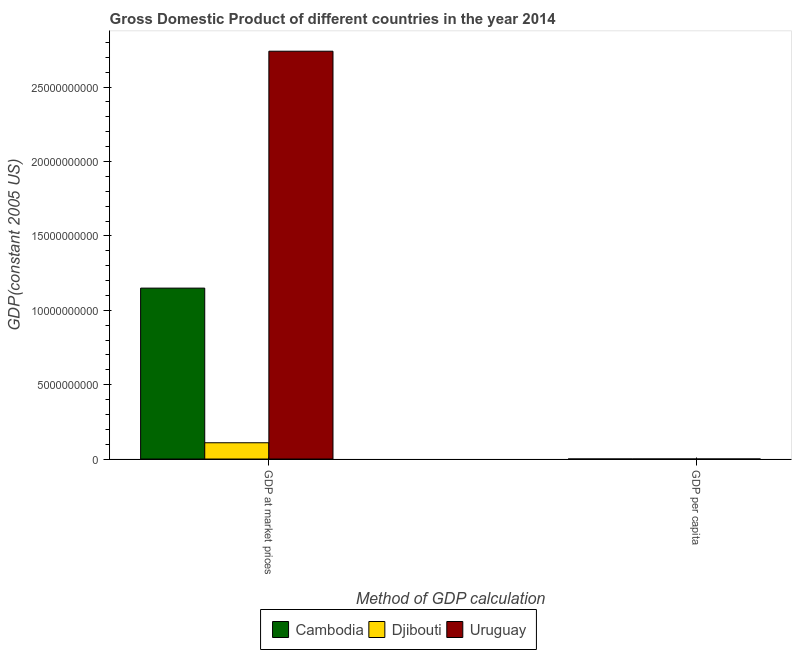How many groups of bars are there?
Provide a short and direct response. 2. Are the number of bars on each tick of the X-axis equal?
Your answer should be very brief. Yes. What is the label of the 2nd group of bars from the left?
Keep it short and to the point. GDP per capita. What is the gdp at market prices in Djibouti?
Your response must be concise. 1.09e+09. Across all countries, what is the maximum gdp per capita?
Provide a short and direct response. 8016.68. Across all countries, what is the minimum gdp at market prices?
Make the answer very short. 1.09e+09. In which country was the gdp at market prices maximum?
Offer a terse response. Uruguay. In which country was the gdp per capita minimum?
Provide a succinct answer. Cambodia. What is the total gdp per capita in the graph?
Give a very brief answer. 1.00e+04. What is the difference between the gdp at market prices in Cambodia and that in Uruguay?
Your answer should be very brief. -1.59e+1. What is the difference between the gdp at market prices in Djibouti and the gdp per capita in Uruguay?
Make the answer very short. 1.09e+09. What is the average gdp per capita per country?
Ensure brevity in your answer.  3338.35. What is the difference between the gdp per capita and gdp at market prices in Uruguay?
Offer a terse response. -2.74e+1. In how many countries, is the gdp at market prices greater than 12000000000 US$?
Offer a very short reply. 1. What is the ratio of the gdp at market prices in Djibouti to that in Uruguay?
Your answer should be very brief. 0.04. Is the gdp per capita in Cambodia less than that in Djibouti?
Give a very brief answer. Yes. What does the 3rd bar from the left in GDP at market prices represents?
Your answer should be very brief. Uruguay. What does the 2nd bar from the right in GDP per capita represents?
Offer a terse response. Djibouti. How many bars are there?
Give a very brief answer. 6. Does the graph contain grids?
Your response must be concise. No. How many legend labels are there?
Offer a very short reply. 3. What is the title of the graph?
Provide a short and direct response. Gross Domestic Product of different countries in the year 2014. What is the label or title of the X-axis?
Your answer should be very brief. Method of GDP calculation. What is the label or title of the Y-axis?
Provide a succinct answer. GDP(constant 2005 US). What is the GDP(constant 2005 US) of Cambodia in GDP at market prices?
Your response must be concise. 1.15e+1. What is the GDP(constant 2005 US) of Djibouti in GDP at market prices?
Give a very brief answer. 1.09e+09. What is the GDP(constant 2005 US) of Uruguay in GDP at market prices?
Your answer should be compact. 2.74e+1. What is the GDP(constant 2005 US) of Cambodia in GDP per capita?
Provide a succinct answer. 749.55. What is the GDP(constant 2005 US) in Djibouti in GDP per capita?
Offer a very short reply. 1248.83. What is the GDP(constant 2005 US) in Uruguay in GDP per capita?
Make the answer very short. 8016.68. Across all Method of GDP calculation, what is the maximum GDP(constant 2005 US) in Cambodia?
Your answer should be very brief. 1.15e+1. Across all Method of GDP calculation, what is the maximum GDP(constant 2005 US) in Djibouti?
Give a very brief answer. 1.09e+09. Across all Method of GDP calculation, what is the maximum GDP(constant 2005 US) in Uruguay?
Provide a succinct answer. 2.74e+1. Across all Method of GDP calculation, what is the minimum GDP(constant 2005 US) of Cambodia?
Your response must be concise. 749.55. Across all Method of GDP calculation, what is the minimum GDP(constant 2005 US) of Djibouti?
Your answer should be very brief. 1248.83. Across all Method of GDP calculation, what is the minimum GDP(constant 2005 US) of Uruguay?
Offer a terse response. 8016.68. What is the total GDP(constant 2005 US) of Cambodia in the graph?
Make the answer very short. 1.15e+1. What is the total GDP(constant 2005 US) in Djibouti in the graph?
Ensure brevity in your answer.  1.09e+09. What is the total GDP(constant 2005 US) of Uruguay in the graph?
Your answer should be compact. 2.74e+1. What is the difference between the GDP(constant 2005 US) of Cambodia in GDP at market prices and that in GDP per capita?
Ensure brevity in your answer.  1.15e+1. What is the difference between the GDP(constant 2005 US) of Djibouti in GDP at market prices and that in GDP per capita?
Offer a terse response. 1.09e+09. What is the difference between the GDP(constant 2005 US) in Uruguay in GDP at market prices and that in GDP per capita?
Your answer should be very brief. 2.74e+1. What is the difference between the GDP(constant 2005 US) of Cambodia in GDP at market prices and the GDP(constant 2005 US) of Djibouti in GDP per capita?
Give a very brief answer. 1.15e+1. What is the difference between the GDP(constant 2005 US) in Cambodia in GDP at market prices and the GDP(constant 2005 US) in Uruguay in GDP per capita?
Provide a succinct answer. 1.15e+1. What is the difference between the GDP(constant 2005 US) in Djibouti in GDP at market prices and the GDP(constant 2005 US) in Uruguay in GDP per capita?
Provide a succinct answer. 1.09e+09. What is the average GDP(constant 2005 US) in Cambodia per Method of GDP calculation?
Provide a succinct answer. 5.74e+09. What is the average GDP(constant 2005 US) of Djibouti per Method of GDP calculation?
Your answer should be very brief. 5.47e+08. What is the average GDP(constant 2005 US) in Uruguay per Method of GDP calculation?
Your answer should be compact. 1.37e+1. What is the difference between the GDP(constant 2005 US) in Cambodia and GDP(constant 2005 US) in Djibouti in GDP at market prices?
Your response must be concise. 1.04e+1. What is the difference between the GDP(constant 2005 US) of Cambodia and GDP(constant 2005 US) of Uruguay in GDP at market prices?
Your response must be concise. -1.59e+1. What is the difference between the GDP(constant 2005 US) in Djibouti and GDP(constant 2005 US) in Uruguay in GDP at market prices?
Provide a succinct answer. -2.63e+1. What is the difference between the GDP(constant 2005 US) of Cambodia and GDP(constant 2005 US) of Djibouti in GDP per capita?
Give a very brief answer. -499.28. What is the difference between the GDP(constant 2005 US) in Cambodia and GDP(constant 2005 US) in Uruguay in GDP per capita?
Give a very brief answer. -7267.13. What is the difference between the GDP(constant 2005 US) of Djibouti and GDP(constant 2005 US) of Uruguay in GDP per capita?
Your answer should be very brief. -6767.85. What is the ratio of the GDP(constant 2005 US) in Cambodia in GDP at market prices to that in GDP per capita?
Ensure brevity in your answer.  1.53e+07. What is the ratio of the GDP(constant 2005 US) in Djibouti in GDP at market prices to that in GDP per capita?
Your response must be concise. 8.76e+05. What is the ratio of the GDP(constant 2005 US) of Uruguay in GDP at market prices to that in GDP per capita?
Provide a short and direct response. 3.42e+06. What is the difference between the highest and the second highest GDP(constant 2005 US) of Cambodia?
Make the answer very short. 1.15e+1. What is the difference between the highest and the second highest GDP(constant 2005 US) in Djibouti?
Make the answer very short. 1.09e+09. What is the difference between the highest and the second highest GDP(constant 2005 US) of Uruguay?
Give a very brief answer. 2.74e+1. What is the difference between the highest and the lowest GDP(constant 2005 US) in Cambodia?
Give a very brief answer. 1.15e+1. What is the difference between the highest and the lowest GDP(constant 2005 US) of Djibouti?
Provide a short and direct response. 1.09e+09. What is the difference between the highest and the lowest GDP(constant 2005 US) in Uruguay?
Offer a very short reply. 2.74e+1. 